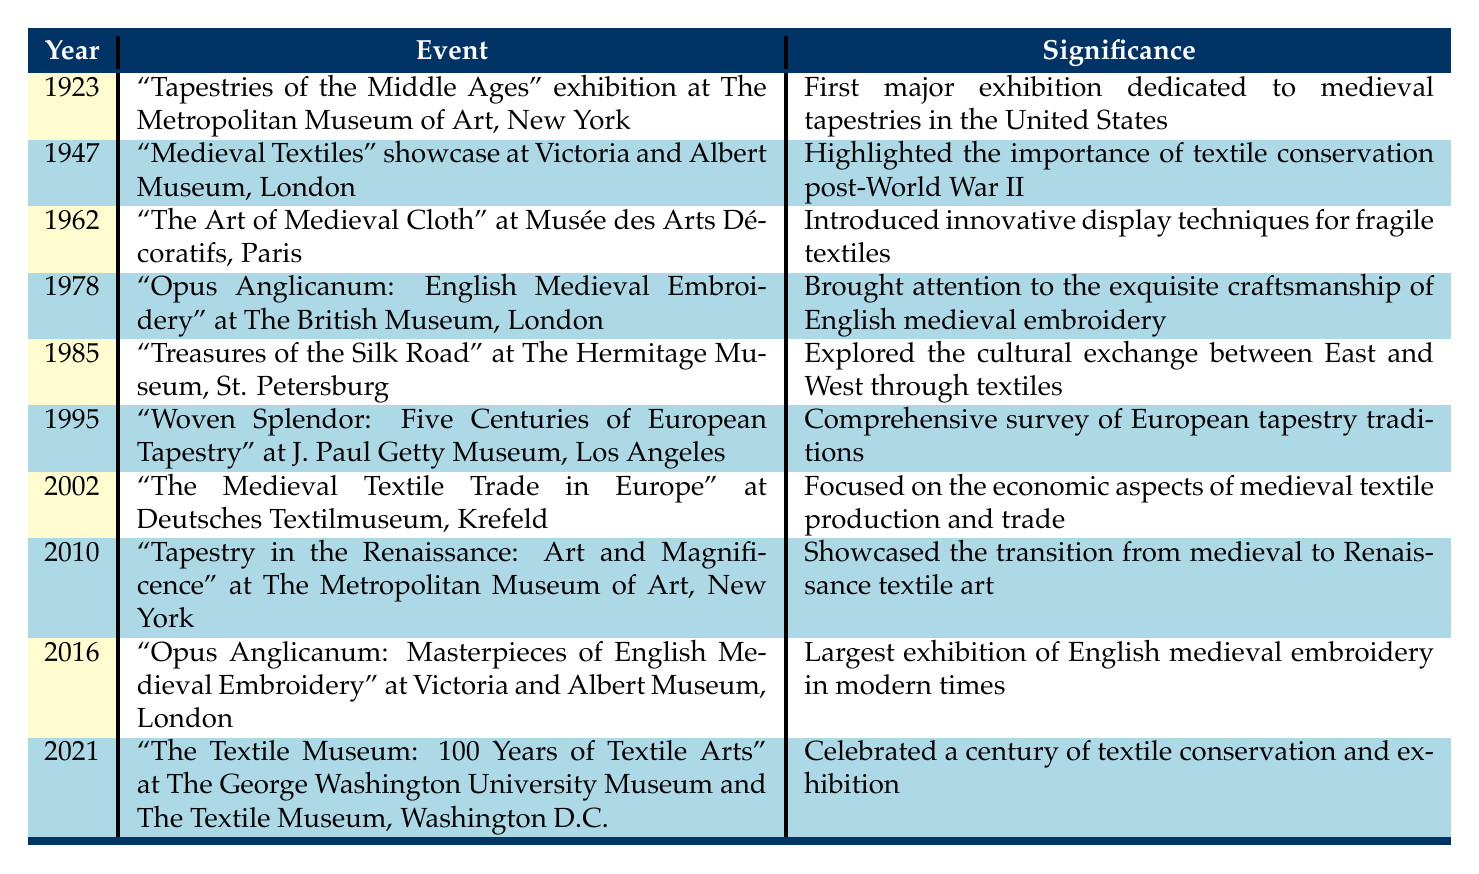What year was the first major exhibition dedicated to medieval tapestries in the United States? The table indicates that the event titled "Tapestries of the Middle Ages" took place in 1923 at The Metropolitan Museum of Art. Therefore, the year is 1923.
Answer: 1923 Which exhibition highlighted the importance of textile conservation post-World War II? According to the table, the "Medieval Textiles" showcase at the Victoria and Albert Museum in 1947 specifically emphasized the need for textile conservation following the war.
Answer: Medieval Textiles How many exhibitions took place in the 2000s? The table lists two exhibitions during the 2000s: one in 2002 and another in 2010. Therefore, the count is 2.
Answer: 2 Did any exhibition take place that focused on the economic aspects of medieval textile production? The table presents the exhibition titled "The Medieval Textile Trade in Europe" at Deutsches Textilmuseum in 2002, which explicitly focused on the economic aspects of medieval textile production. Hence, the answer is yes.
Answer: Yes What was the significance of the exhibition held in 1985 at The Hermitage Museum? The significance of the "Treasures of the Silk Road" exhibition in 1985 is mentioned as exploring the cultural exchange between East and West through textiles.
Answer: Explored cultural exchange between East and West Which exhibition was the largest of English medieval embroidery in modern times? The table points out that "Opus Anglicanum: Masterpieces of English Medieval Embroidery" at the Victoria and Albert Museum in 2016 was the largest exhibition devoted to English medieval embroidery in modern times.
Answer: Opus Anglicanum: Masterpieces of English Medieval Embroidery What is the significance of the exhibition held in 2010 at The Metropolitan Museum of Art? The significance of the "Tapestry in the Renaissance: Art and Magnificence" exhibition in 2010 is to showcase the transition from medieval to Renaissance textile art, as noted in the table.
Answer: Transition from medieval to Renaissance textile art How does the total number of exhibitions from the 1920s compare to those in the 2010s? There was 1 exhibition in the 1920s (1923) and 2 exhibitions in the 2010s (2010, 2016). Since 2 is greater than 1, there are more exhibitions in the 2010s.
Answer: More in the 2010s What was the overall theme for the exhibition celebrated in 2021? The "The Textile Museum: 100 Years of Textile Arts" exhibition in 2021 celebrated a century of textile conservation and exhibition, as per the data provided.
Answer: Celebrated century of textile conservation and exhibition 